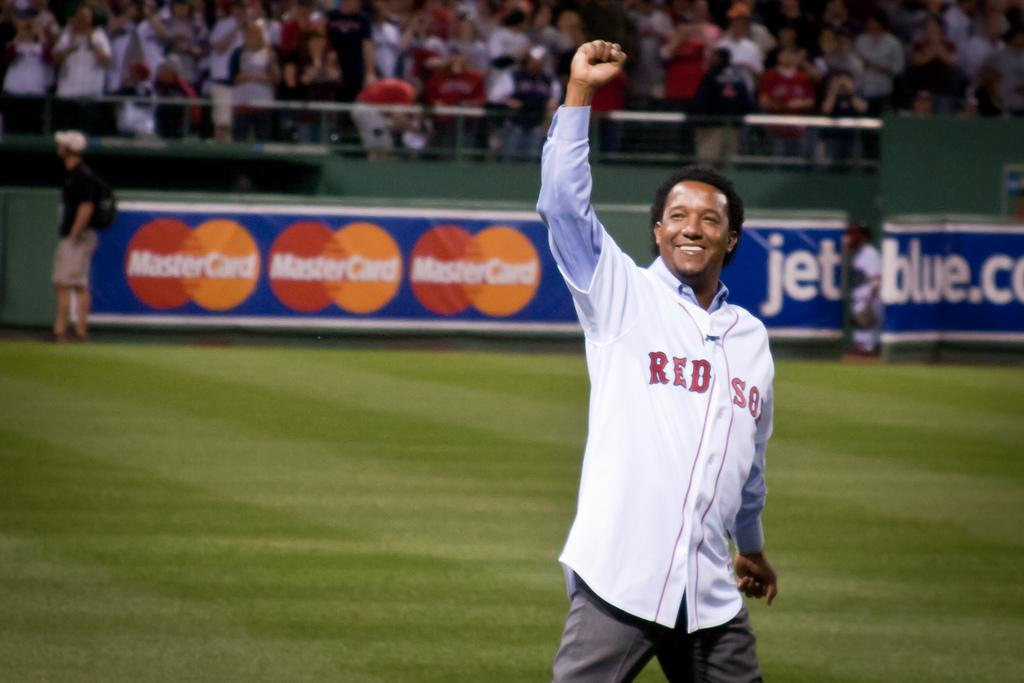<image>
Render a clear and concise summary of the photo. A man wearing a Red Sox shirt stands on a field with an arm raised. 